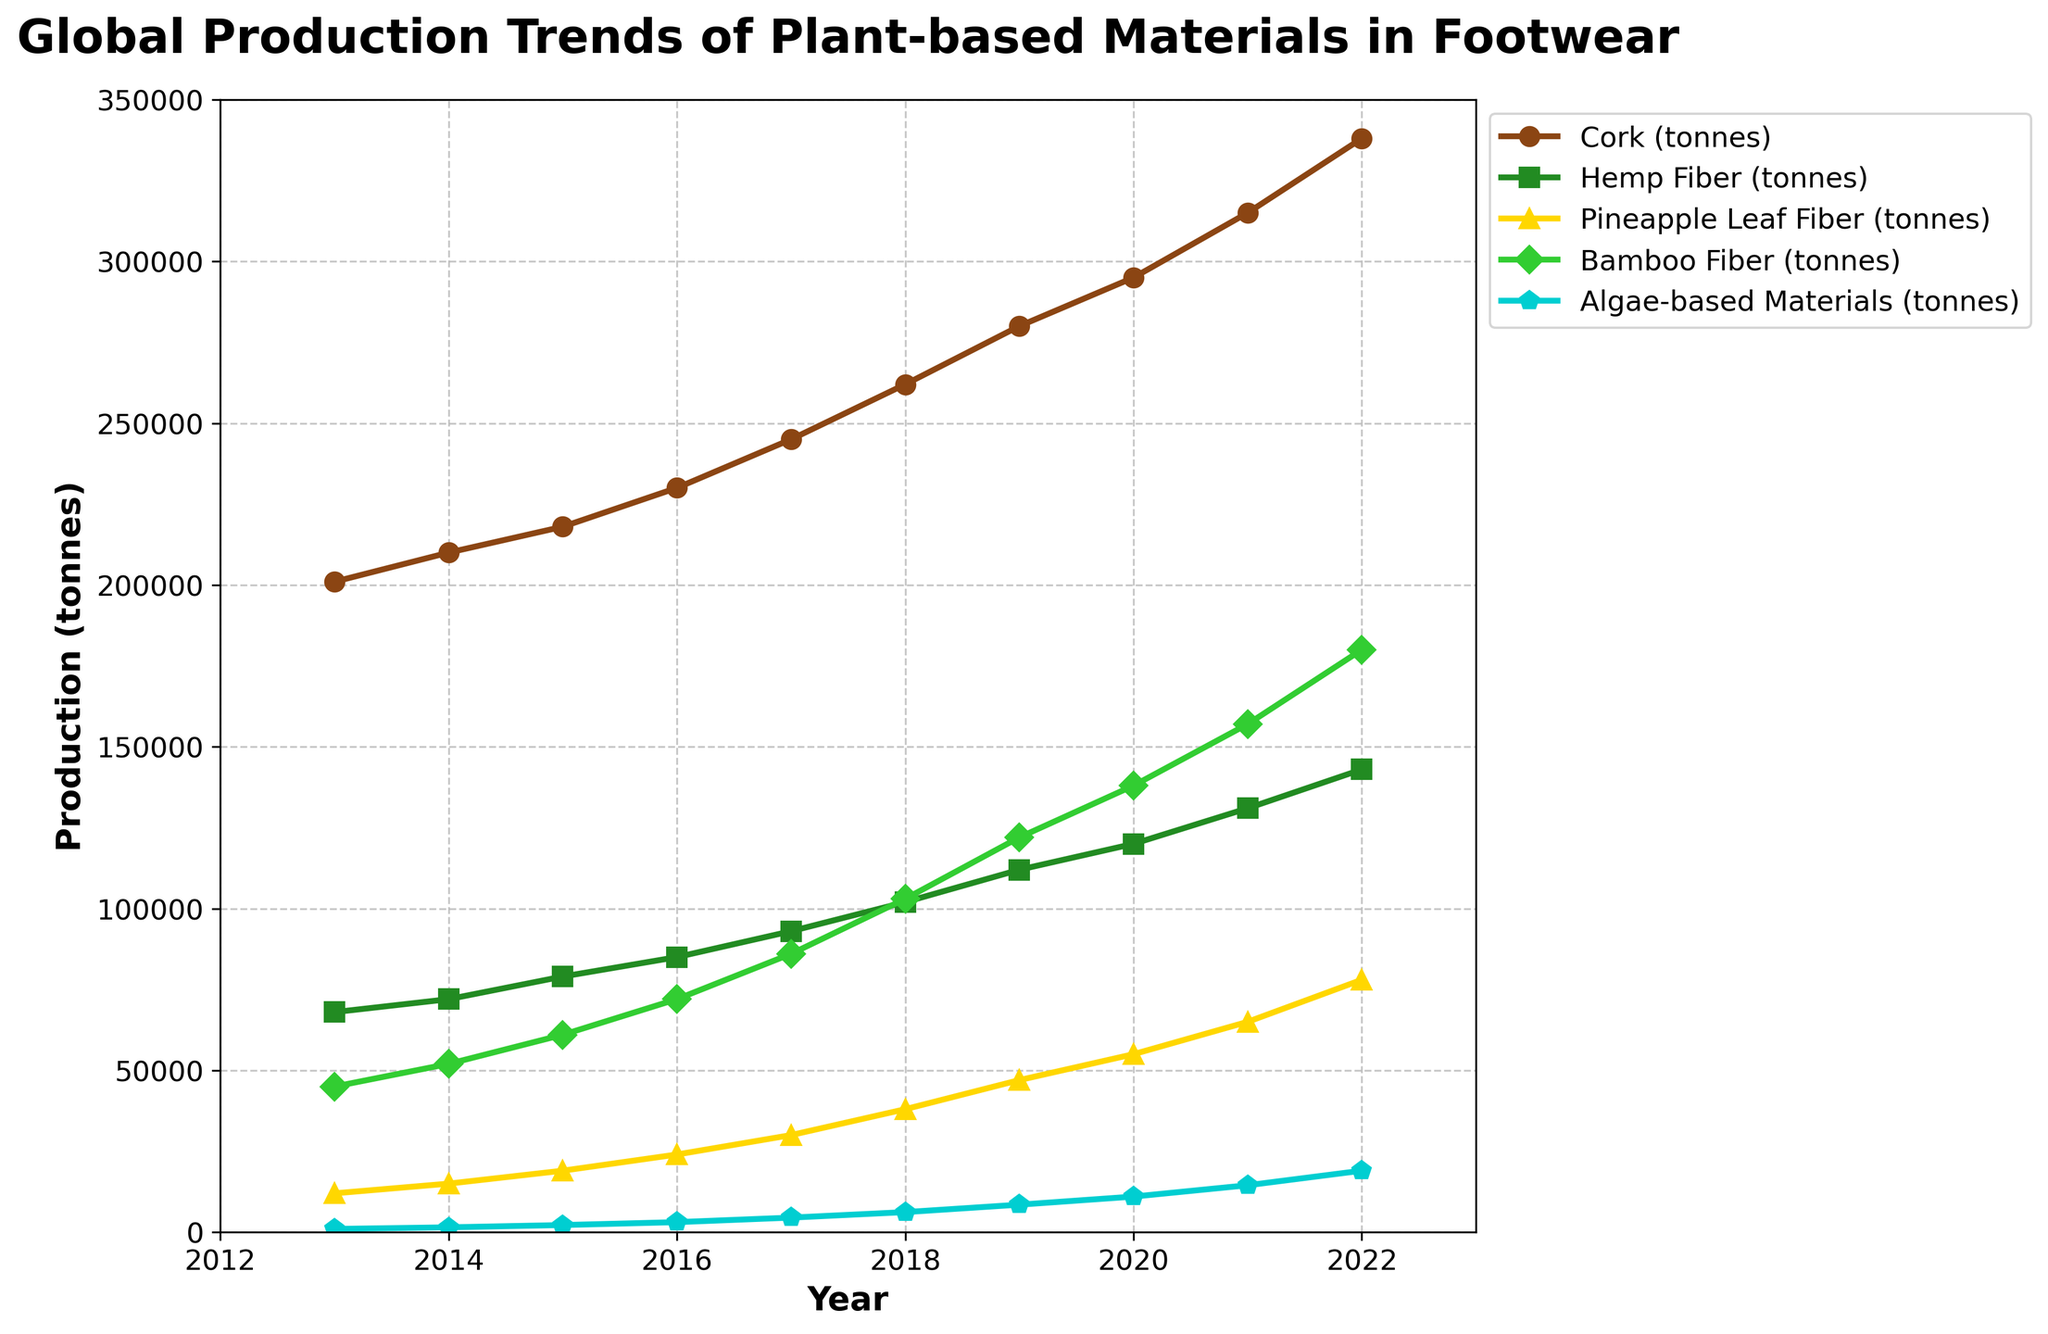How has the production of bamboo fiber changed from 2013 to 2022? To determine the change in bamboo fiber production from 2013 to 2022, subtract the 2013 value (45,000 tonnes) from the 2022 value (180,000 tonnes). So, the change is 180,000 - 45,000 = 135,000 tonnes.
Answer: 135,000 tonnes Which material had the highest production in 2022, and what was the amount? By looking at the 2022 data points on the chart and comparing them, cork produced the most with 338,000 tonnes.
Answer: Cork, 338,000 tonnes What is the trend in algae-based materials production over the decade? Observing the line for algae-based materials from 2013 (1,000 tonnes) to 2022 (19,000 tonnes), it shows a steady increase each year.
Answer: Steady increase What's the average annual production of hemp fiber over the decade? First, sum the production values for hemp fiber from 2013 to 2022 (68,000 + 72,000 + 79,000 + 85,000 + 93,000 + 102,000 + 112,000 + 120,000 + 131,000 + 143,000 = 1,005,000). Then, divide by 10 years to find the average: 1,005,000 / 10 = 100,500 tonnes.
Answer: 100,500 tonnes In which year did pineapple leaf fiber production see the largest absolute increase compared to the previous year? Calculate the year-to-year differences and find the maximum: 
2014-2013 (15,000 - 12,000 = 3,000), 
2015-2014 (19,000 - 15,000 = 4,000), 
2016-2015 (24,000 - 19,000 = 5,000), 
2017-2016 (30,000 - 24,000 = 6,000), 
2018-2017 (38,000 - 30,000 = 8,000), 
2019-2018 (47,000 - 38,000 = 9,000),
2020-2019 (55,000 - 47,000 = 8,000), 
2021-2020 (65,000 - 55,000 = 10,000), 
2022-2021 (78,000 - 65,000 = 13,000). The largest increase was in 2022.
Answer: 2022 Between cork and hemp fiber, which material saw a greater overall increase in production from 2013 to 2022, and by how much? First, calculate the increase for each:
Cork: 338,000 - 201,000 = 137,000 tonnes,
Hemp fiber: 143,000 - 68,000 = 75,000 tonnes. 
Cork saw a greater increase of 137,000 tonnes.
Answer: Cork, 137,000 tonnes In what year did bamboo fiber production surpass 100,000 tonnes? By looking at the progression on the chart, bamboo fiber production surpassed 100,000 tonnes in 2018.
Answer: 2018 What is the combined production of all materials in 2020? Add the production values for all materials in 2020: 
Cork (295,000) + Hemp Fiber (120,000) + Pineapple Leaf Fiber (55,000) + Bamboo Fiber (138,000) + Algae-based Materials (11,000) = 619,000 tonnes.
Answer: 619,000 tonnes 